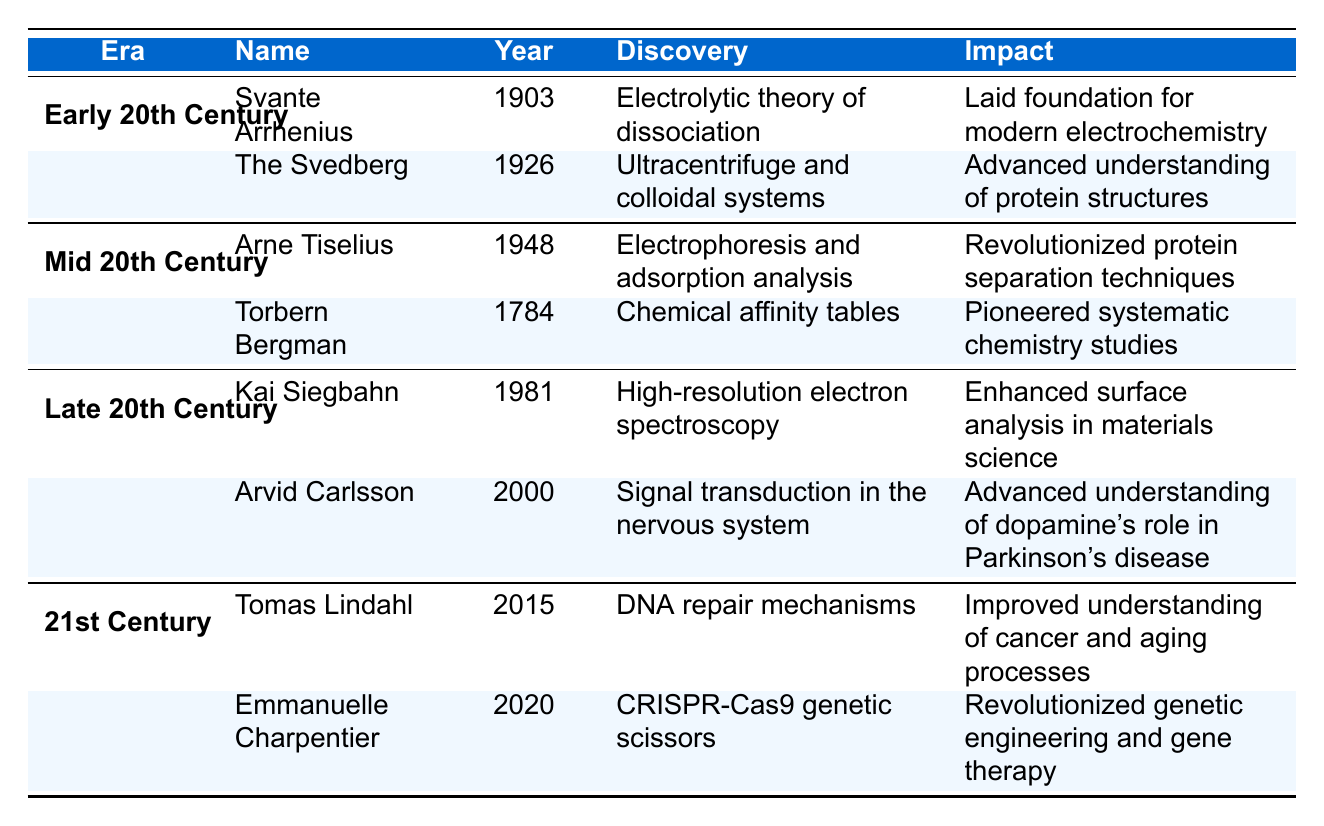What year did Svante Arrhenius win the Nobel Prize in Chemistry? According to the table, Svante Arrhenius received the Nobel Prize in 1903, as listed in the first row under the "Early 20th Century" era.
Answer: 1903 How many Nobel Prize winners are listed from the Late 20th Century? The table shows two winners listed under the "Late 20th Century", which includes Kai Siegbahn and Arvid Carlsson.
Answer: 2 What was Arne Tiselius's discovery? The table states that Arne Tiselius's discovery in 1948 was "Electrophoresis and adsorption analysis" found in the "Mid 20th Century" section.
Answer: Electrophoresis and adsorption analysis Which discovery is associated with Emmanuelle Charpentier? Emmanuelle Charpentier's discovery, according to the table, is "CRISPR-Cas9 genetic scissors" listed under the "21st Century" section.
Answer: CRISPR-Cas9 genetic scissors What impact did the Svedberg's discovery have? The table indicates that the Svedberg's discovery advanced the understanding of protein structures, which is mentioned in the last column corresponding to his 1926 entry.
Answer: Advanced understanding of protein structures Is it true that Torbern Bergman won the Nobel Prize in Chemistry in the 20th century? The table shows that Torbern Bergman won the prize in 1784, which is not in the 20th century but rather the 18th century, making the statement false.
Answer: False Which scientist had the earliest Nobel Prize awarded among those listed? By examining the years mentioned in the table, it can be noted that Torbern Bergman received his award in 1784, which is earlier than any other scientist on the list.
Answer: Torbern Bergman What is the difference in years between the awards of Kai Siegbahn and Arvid Carlsson? The table shows that Kai Siegbahn won in 1981 and Arvid Carlsson in 2000. The difference is 2000 - 1981 = 19 years.
Answer: 19 years How many discoveries are named in the 21st Century era? There are two scientists listed under the "21st Century" section: Tomas Lindahl and Emmanuelle Charpentier, each associated with their respective discoveries, indicating that there are two discoveries.
Answer: 2 Which discovery revolutionized genetic engineering? According to the “21st Century” section of the table, Emmanuelle Charpentier’s discovery, "CRISPR-Cas9 genetic scissors," is stated to have revolutionized genetic engineering.
Answer: CRISPR-Cas9 genetic scissors 